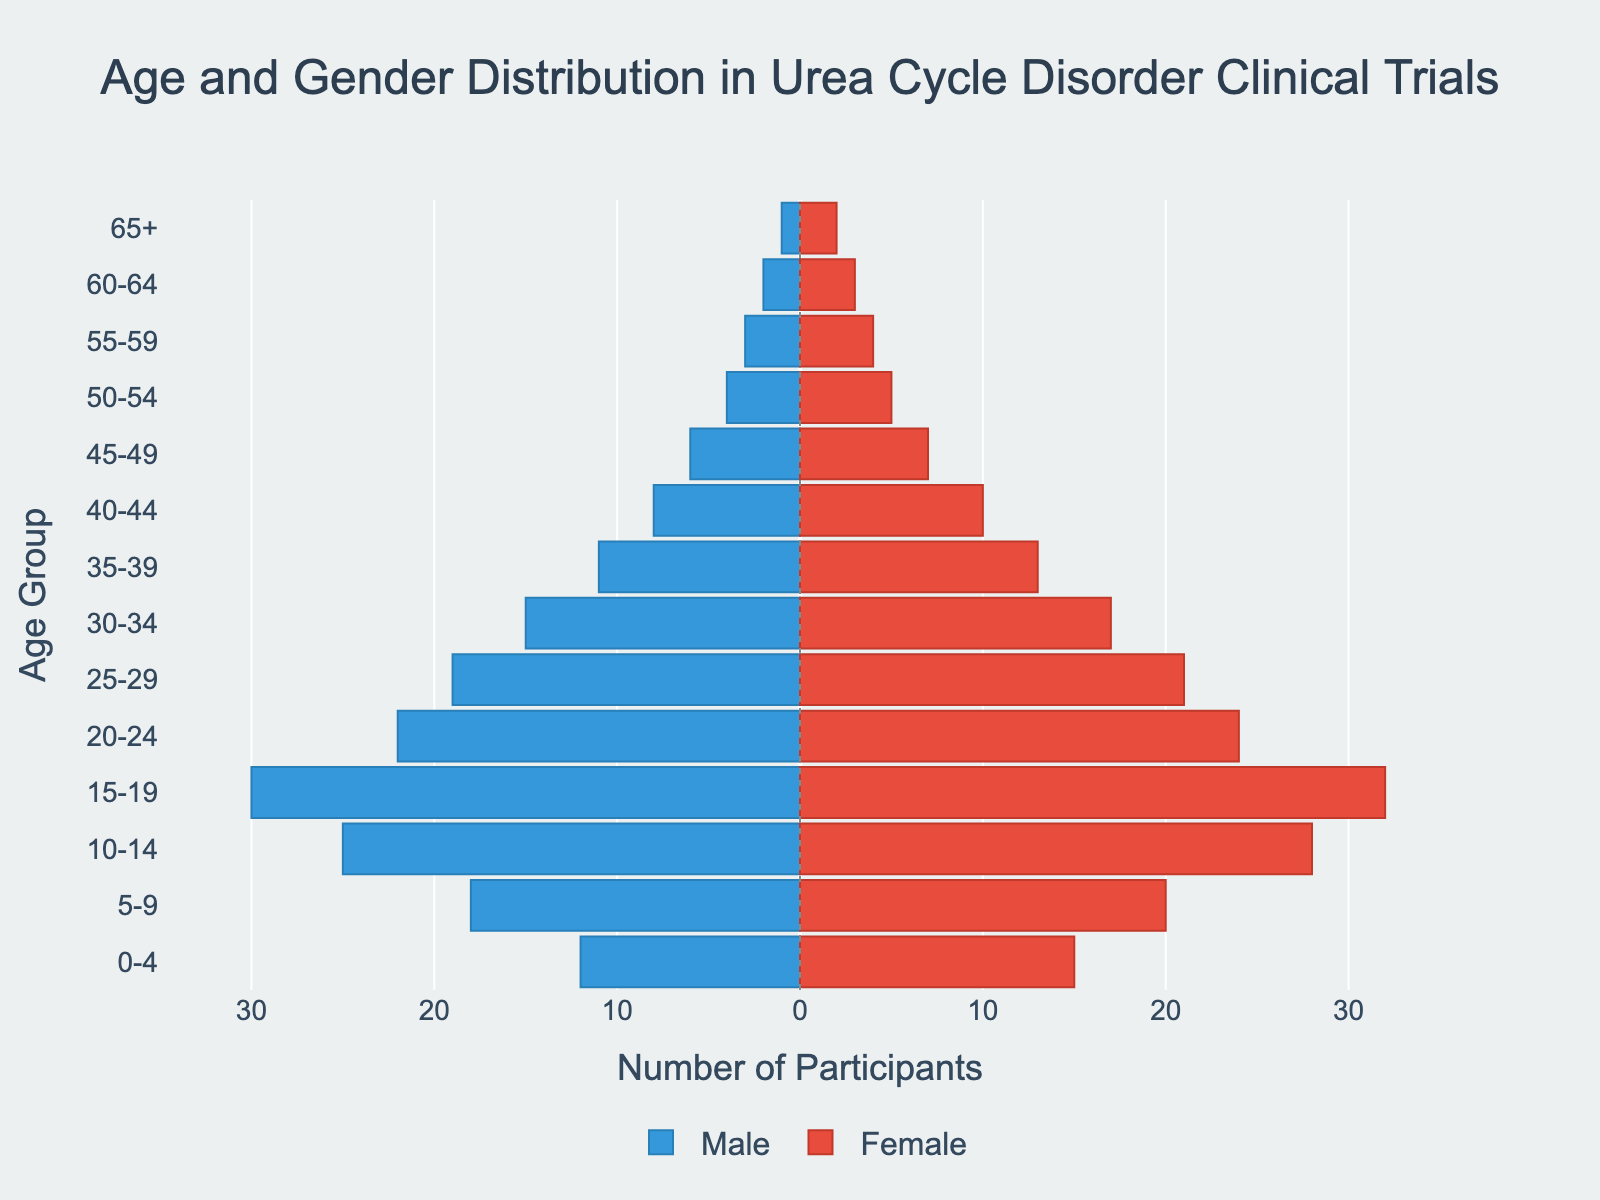What is the title of the figure? The title of the figure is written at the top center of the population pyramid. It reads: "Age and Gender Distribution in Urea Cycle Disorder Clinical Trials".
Answer: Age and Gender Distribution in Urea Cycle Disorder Clinical Trials What is the age group with the highest number of male participants? The age group with the highest number of male participants is shown by the longest blue bar extending to the left. This is the "15-19" age group.
Answer: 15-19 Which gender has more participants in the 10-14 age group? To determine which gender has more participants in the 10-14 age group, compare the lengths of the blue and red bars corresponding to that age group. The red bar for females is longer than the blue bar for males.
Answer: Female How many female participants are there in the 0-4 age group? The number of female participants in the 0-4 age group is indicated by the length of the red bar for that group. The red bar shows a value of 15.
Answer: 15 What is the total number of participants in the 50-54 age group? To find the total number of participants in the 50-54 age group, sum the values of male and female participants. The male bar shows 4 participants, and the female bar shows 5 participants. Thus, the total is 4 + 5 = 9.
Answer: 9 Which age group has an equal number of male and female participants? An age group with an equal number of male and female participants will have blue and red bars of equal length. The "15-19" age group has the closest values with 30 males and 32 females, but none are exactly equal. However, the "65+" age group has the closest equality with 1 male and 2 females.
Answer: None (Closest is 65+ with near equality) Is there any age group with zero participants? In the population pyramid, all age groups show bars extending to the left and right, indicating that no age group has zero participants.
Answer: No How many total participants are there in the 30-34 age group? Add the number of male and female participants in the 30-34 age group. The male bar shows 15 participants, and the female bar shows 17 participants. Thus, the total is 15 + 17 = 32.
Answer: 32 What is the difference between the number of males and females in the 20-24 age group? To find the difference between the number of males and females in the 20-24 age group, subtract the smaller value from the larger value. There are 22 males and 24 females, so the difference is 24 - 22 = 2.
Answer: 2 Which age group has the least number of total participants? To find the age group with the least number of total participants, look for the shortest combined length of blue and red bars. The age group "65+" has the least participants with only 1 male and 2 females, totaling 3.
Answer: 65+ 